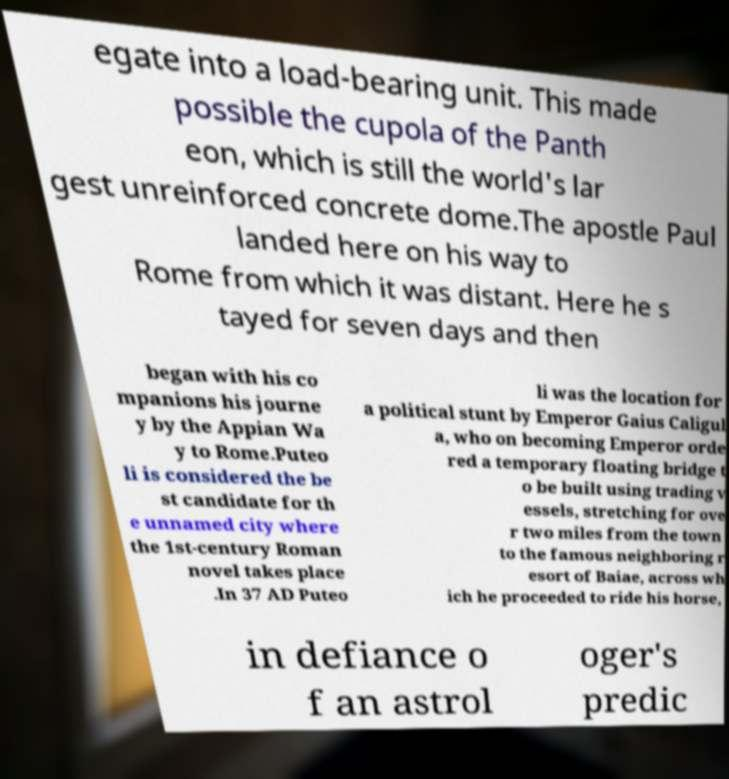There's text embedded in this image that I need extracted. Can you transcribe it verbatim? egate into a load-bearing unit. This made possible the cupola of the Panth eon, which is still the world's lar gest unreinforced concrete dome.The apostle Paul landed here on his way to Rome from which it was distant. Here he s tayed for seven days and then began with his co mpanions his journe y by the Appian Wa y to Rome.Puteo li is considered the be st candidate for th e unnamed city where the 1st-century Roman novel takes place .In 37 AD Puteo li was the location for a political stunt by Emperor Gaius Caligul a, who on becoming Emperor orde red a temporary floating bridge t o be built using trading v essels, stretching for ove r two miles from the town to the famous neighboring r esort of Baiae, across wh ich he proceeded to ride his horse, in defiance o f an astrol oger's predic 